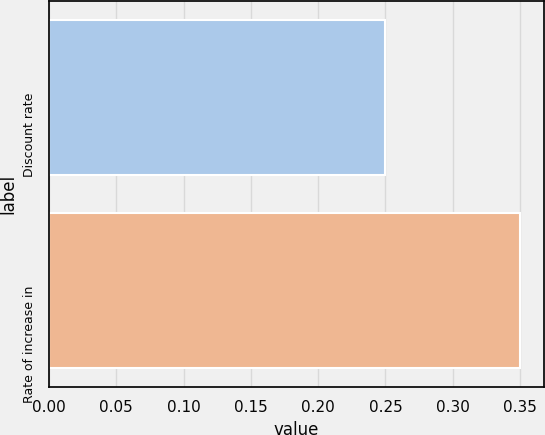<chart> <loc_0><loc_0><loc_500><loc_500><bar_chart><fcel>Discount rate<fcel>Rate of increase in<nl><fcel>0.25<fcel>0.35<nl></chart> 